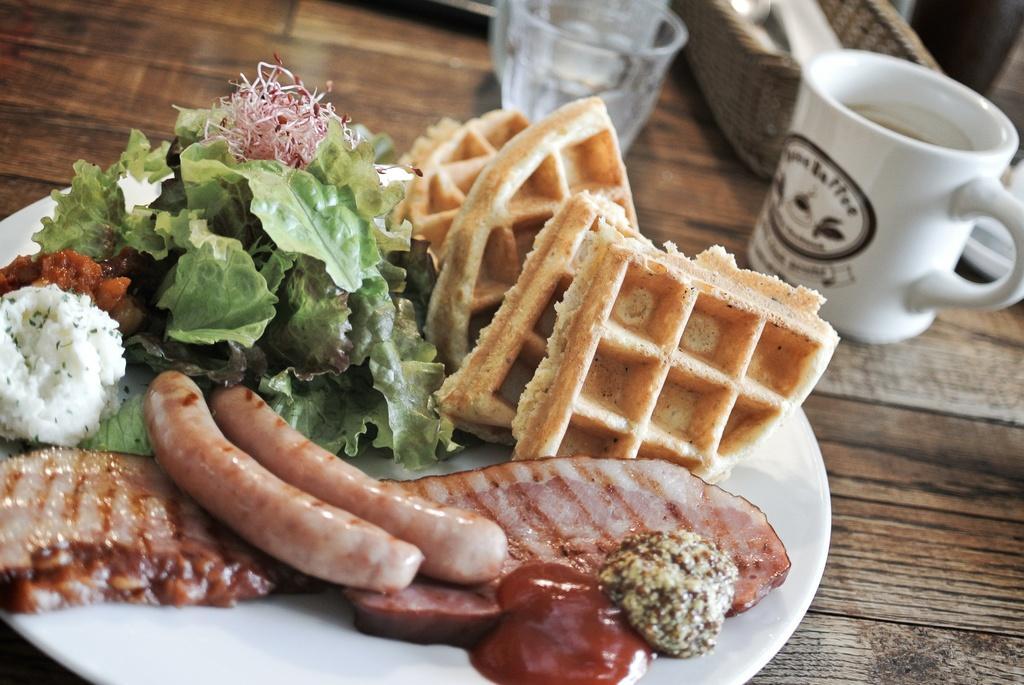Please provide a concise description of this image. In this image we can see a plate of food items. We can also see the glasses, cup and a basket on the table. 